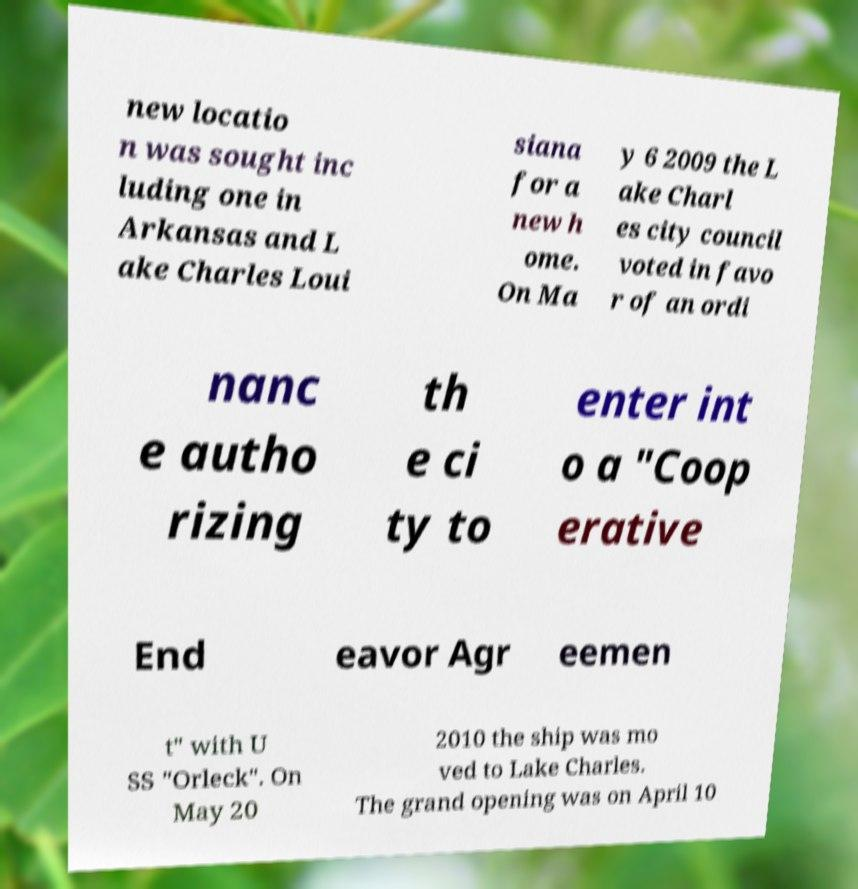Please read and relay the text visible in this image. What does it say? new locatio n was sought inc luding one in Arkansas and L ake Charles Loui siana for a new h ome. On Ma y 6 2009 the L ake Charl es city council voted in favo r of an ordi nanc e autho rizing th e ci ty to enter int o a "Coop erative End eavor Agr eemen t" with U SS "Orleck". On May 20 2010 the ship was mo ved to Lake Charles. The grand opening was on April 10 